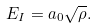<formula> <loc_0><loc_0><loc_500><loc_500>E _ { I } = a _ { 0 } \sqrt { \rho } .</formula> 